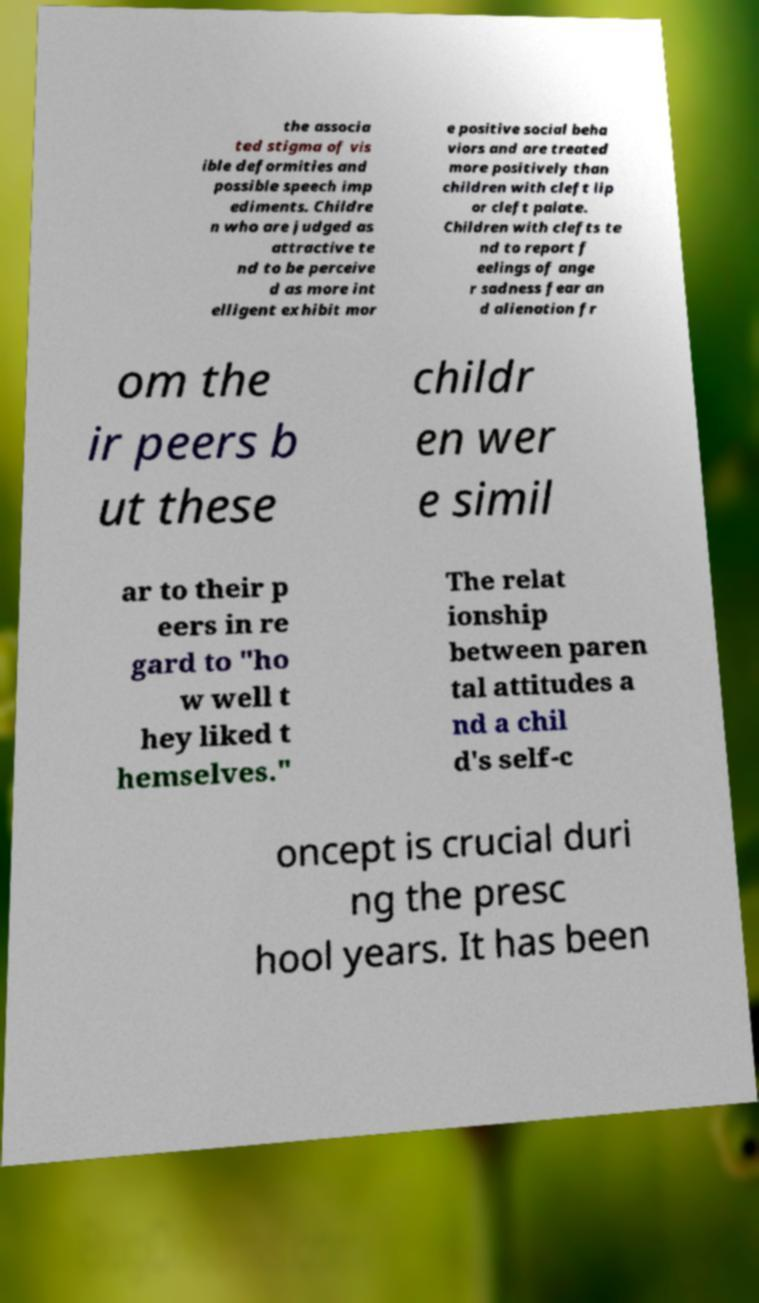Please identify and transcribe the text found in this image. the associa ted stigma of vis ible deformities and possible speech imp ediments. Childre n who are judged as attractive te nd to be perceive d as more int elligent exhibit mor e positive social beha viors and are treated more positively than children with cleft lip or cleft palate. Children with clefts te nd to report f eelings of ange r sadness fear an d alienation fr om the ir peers b ut these childr en wer e simil ar to their p eers in re gard to "ho w well t hey liked t hemselves." The relat ionship between paren tal attitudes a nd a chil d's self-c oncept is crucial duri ng the presc hool years. It has been 